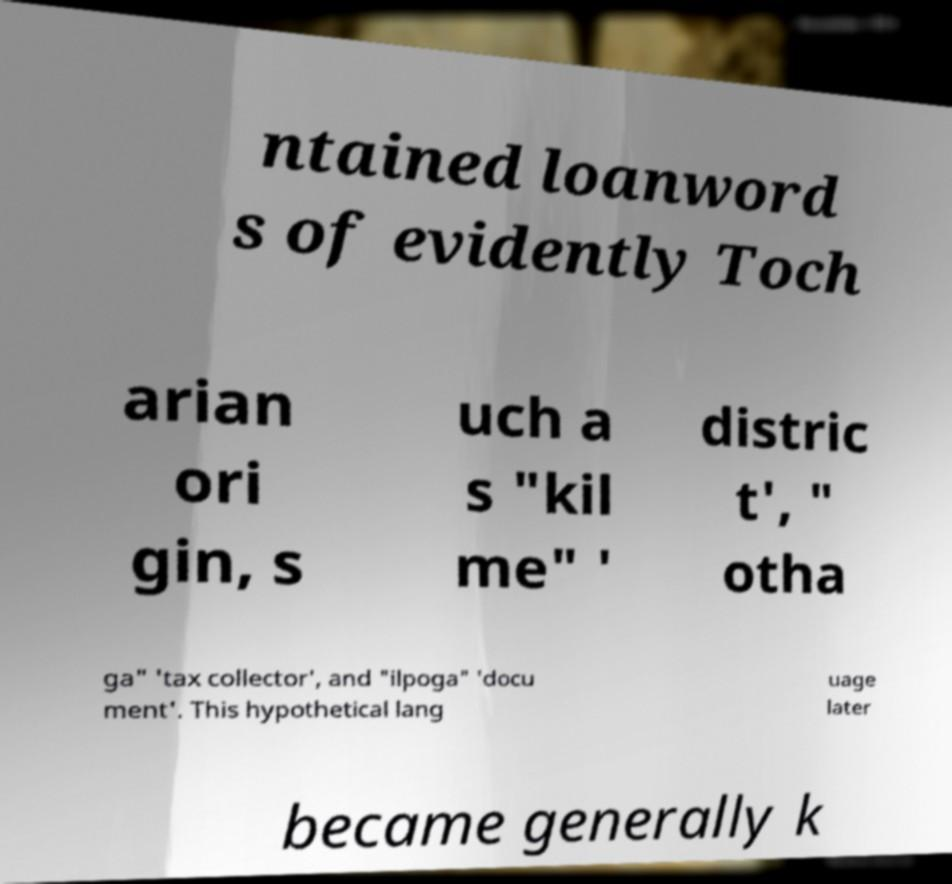Could you extract and type out the text from this image? ntained loanword s of evidently Toch arian ori gin, s uch a s "kil me" ' distric t', " otha ga" 'tax collector', and "ilpoga" 'docu ment'. This hypothetical lang uage later became generally k 